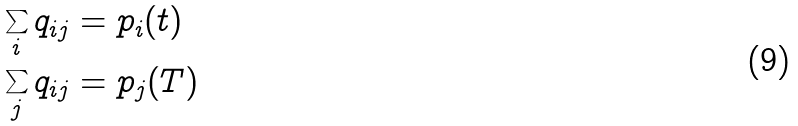<formula> <loc_0><loc_0><loc_500><loc_500>\sum _ { i } q _ { i j } & = p _ { i } ( t ) \\ \sum _ { j } q _ { i j } & = p _ { j } ( T )</formula> 